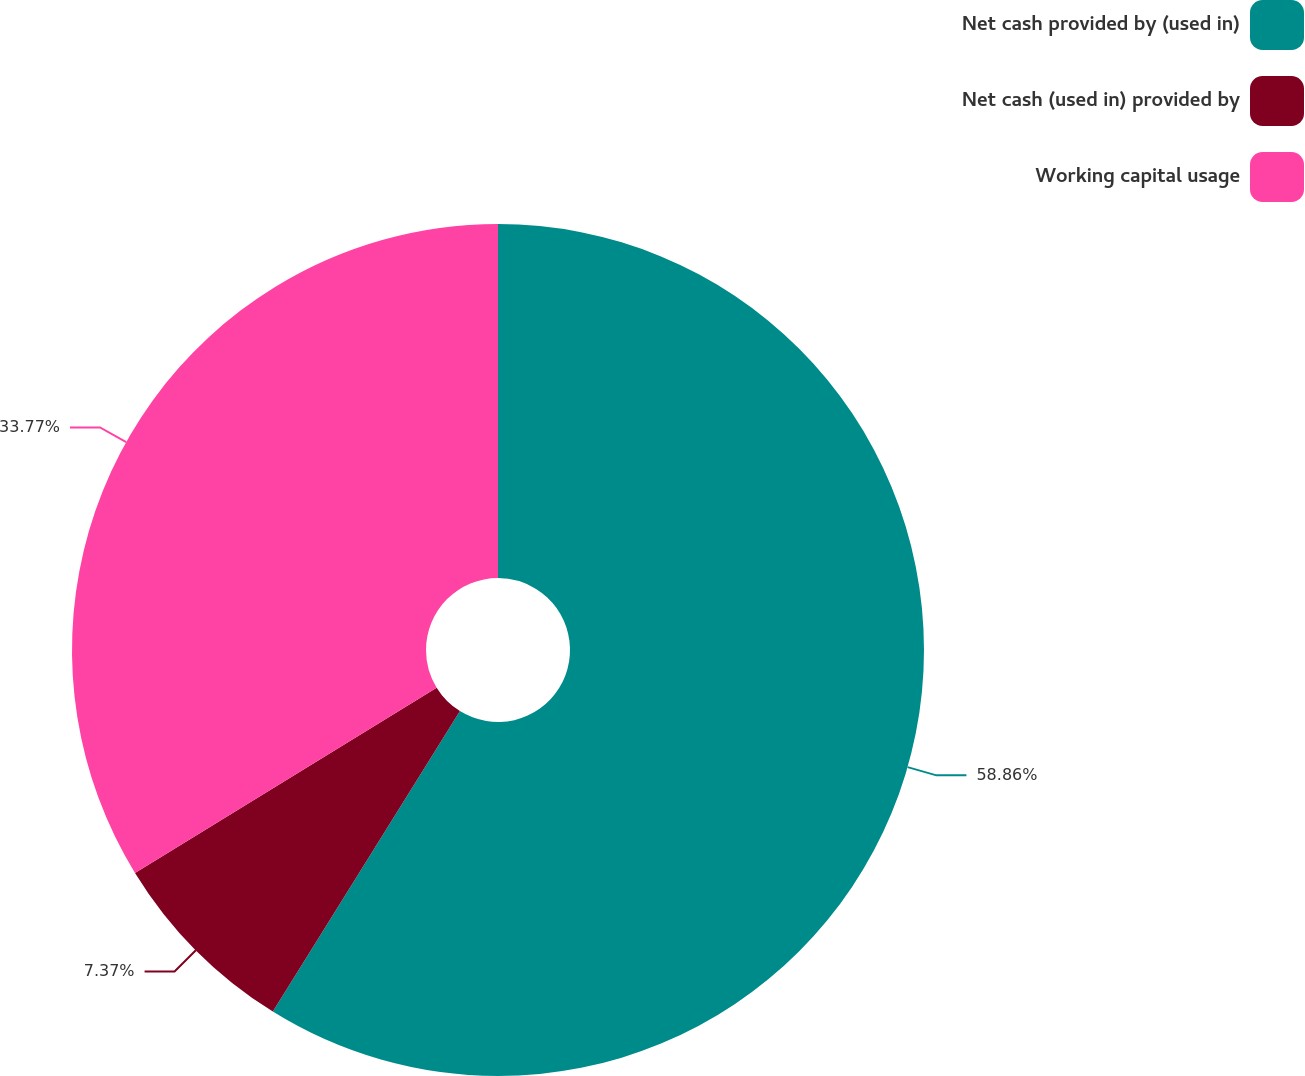<chart> <loc_0><loc_0><loc_500><loc_500><pie_chart><fcel>Net cash provided by (used in)<fcel>Net cash (used in) provided by<fcel>Working capital usage<nl><fcel>58.87%<fcel>7.37%<fcel>33.77%<nl></chart> 